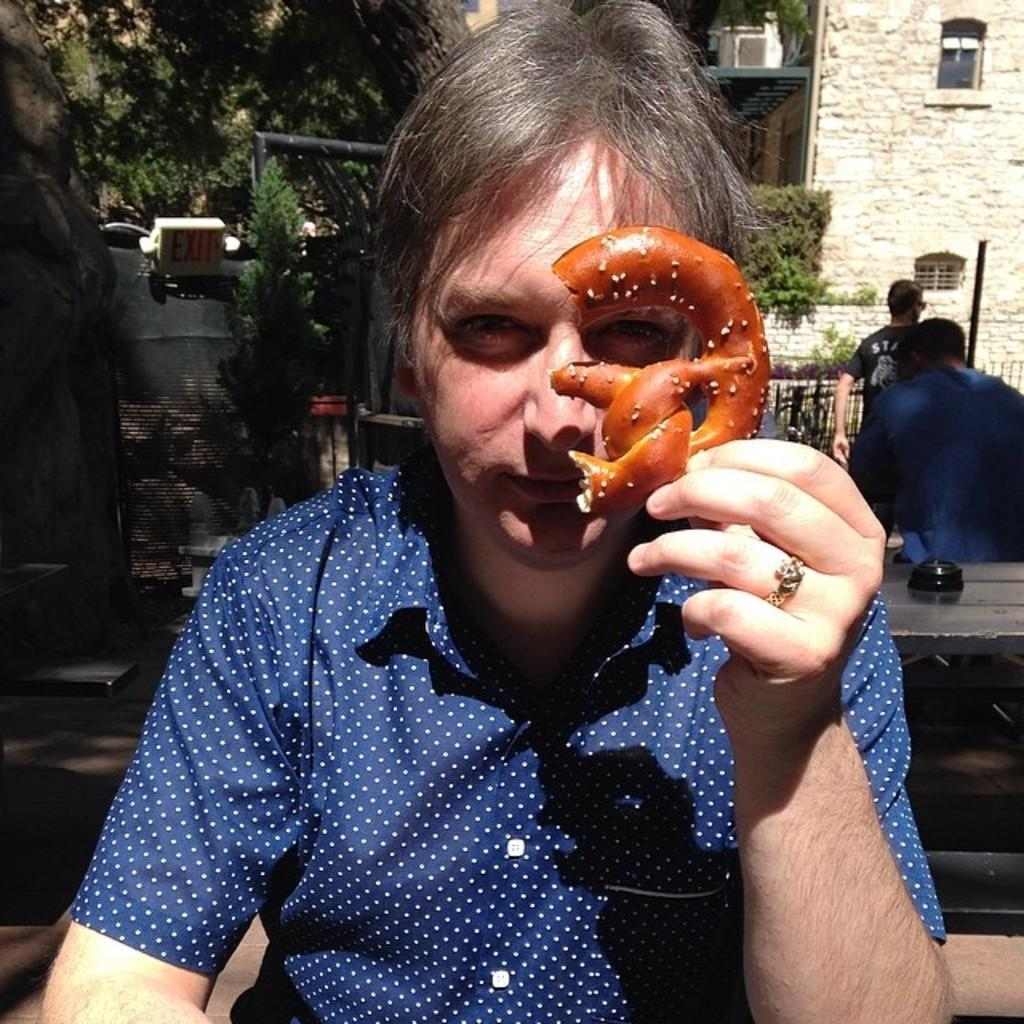What can be seen in the image? There is a person in the image. What is the person holding in their hand? The person is holding an object in their hand. What can be seen in the background of the image? There are trees, signs, and a building in the background of the image. Are there any other people visible in the image? Yes, there are other persons in the background of the image. What type of oil can be seen dripping from the person's mouth in the image? There is no oil or mouth visible in the image; it only features a person holding an object and the background elements mentioned earlier. 